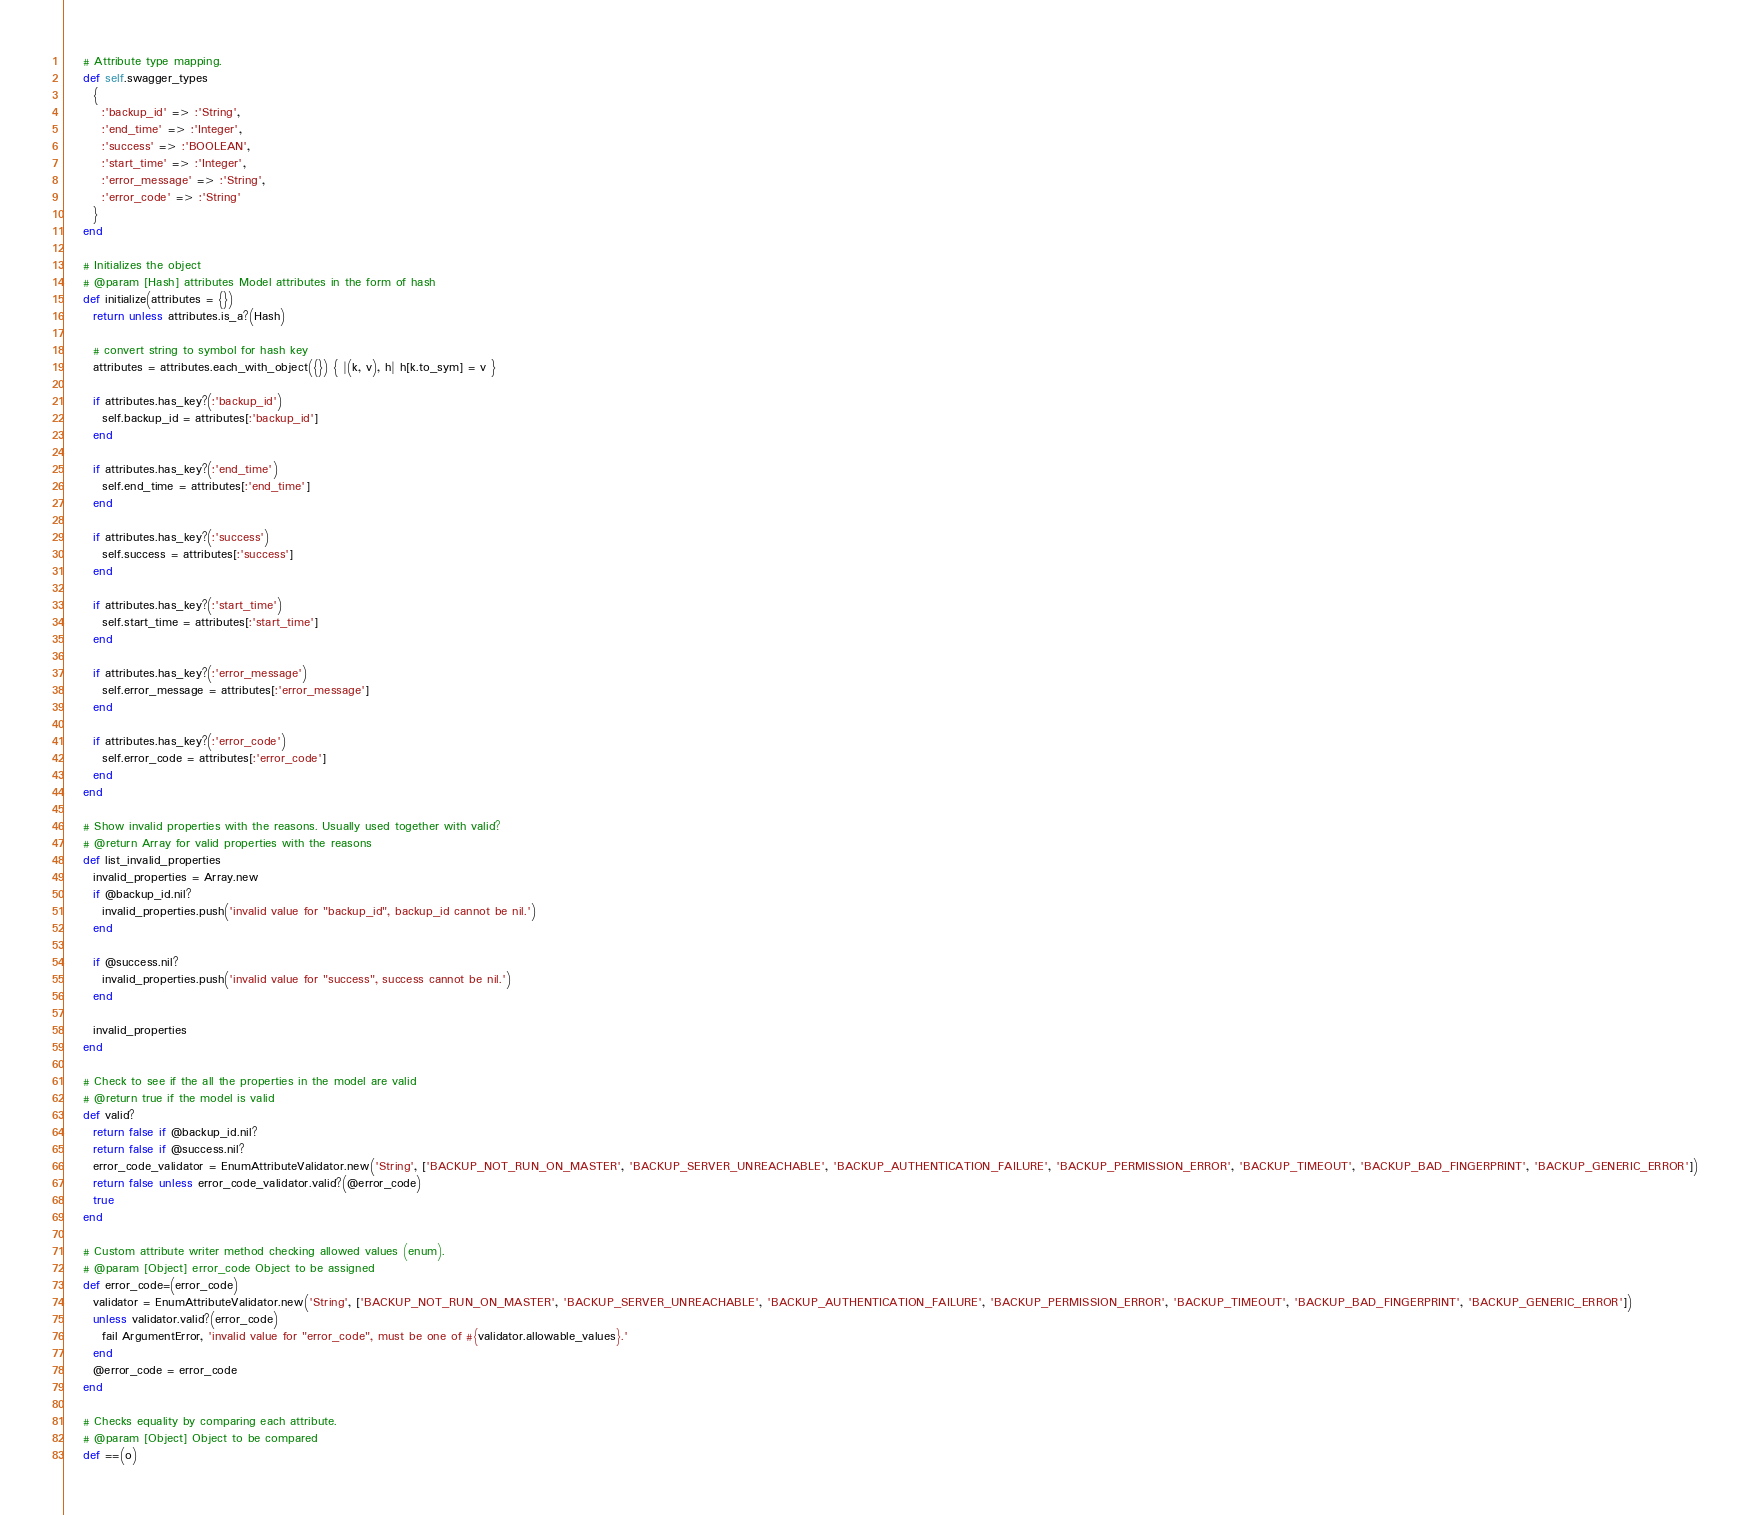Convert code to text. <code><loc_0><loc_0><loc_500><loc_500><_Ruby_>
    # Attribute type mapping.
    def self.swagger_types
      {
        :'backup_id' => :'String',
        :'end_time' => :'Integer',
        :'success' => :'BOOLEAN',
        :'start_time' => :'Integer',
        :'error_message' => :'String',
        :'error_code' => :'String'
      }
    end

    # Initializes the object
    # @param [Hash] attributes Model attributes in the form of hash
    def initialize(attributes = {})
      return unless attributes.is_a?(Hash)

      # convert string to symbol for hash key
      attributes = attributes.each_with_object({}) { |(k, v), h| h[k.to_sym] = v }

      if attributes.has_key?(:'backup_id')
        self.backup_id = attributes[:'backup_id']
      end

      if attributes.has_key?(:'end_time')
        self.end_time = attributes[:'end_time']
      end

      if attributes.has_key?(:'success')
        self.success = attributes[:'success']
      end

      if attributes.has_key?(:'start_time')
        self.start_time = attributes[:'start_time']
      end

      if attributes.has_key?(:'error_message')
        self.error_message = attributes[:'error_message']
      end

      if attributes.has_key?(:'error_code')
        self.error_code = attributes[:'error_code']
      end
    end

    # Show invalid properties with the reasons. Usually used together with valid?
    # @return Array for valid properties with the reasons
    def list_invalid_properties
      invalid_properties = Array.new
      if @backup_id.nil?
        invalid_properties.push('invalid value for "backup_id", backup_id cannot be nil.')
      end

      if @success.nil?
        invalid_properties.push('invalid value for "success", success cannot be nil.')
      end

      invalid_properties
    end

    # Check to see if the all the properties in the model are valid
    # @return true if the model is valid
    def valid?
      return false if @backup_id.nil?
      return false if @success.nil?
      error_code_validator = EnumAttributeValidator.new('String', ['BACKUP_NOT_RUN_ON_MASTER', 'BACKUP_SERVER_UNREACHABLE', 'BACKUP_AUTHENTICATION_FAILURE', 'BACKUP_PERMISSION_ERROR', 'BACKUP_TIMEOUT', 'BACKUP_BAD_FINGERPRINT', 'BACKUP_GENERIC_ERROR'])
      return false unless error_code_validator.valid?(@error_code)
      true
    end

    # Custom attribute writer method checking allowed values (enum).
    # @param [Object] error_code Object to be assigned
    def error_code=(error_code)
      validator = EnumAttributeValidator.new('String', ['BACKUP_NOT_RUN_ON_MASTER', 'BACKUP_SERVER_UNREACHABLE', 'BACKUP_AUTHENTICATION_FAILURE', 'BACKUP_PERMISSION_ERROR', 'BACKUP_TIMEOUT', 'BACKUP_BAD_FINGERPRINT', 'BACKUP_GENERIC_ERROR'])
      unless validator.valid?(error_code)
        fail ArgumentError, 'invalid value for "error_code", must be one of #{validator.allowable_values}.'
      end
      @error_code = error_code
    end

    # Checks equality by comparing each attribute.
    # @param [Object] Object to be compared
    def ==(o)</code> 